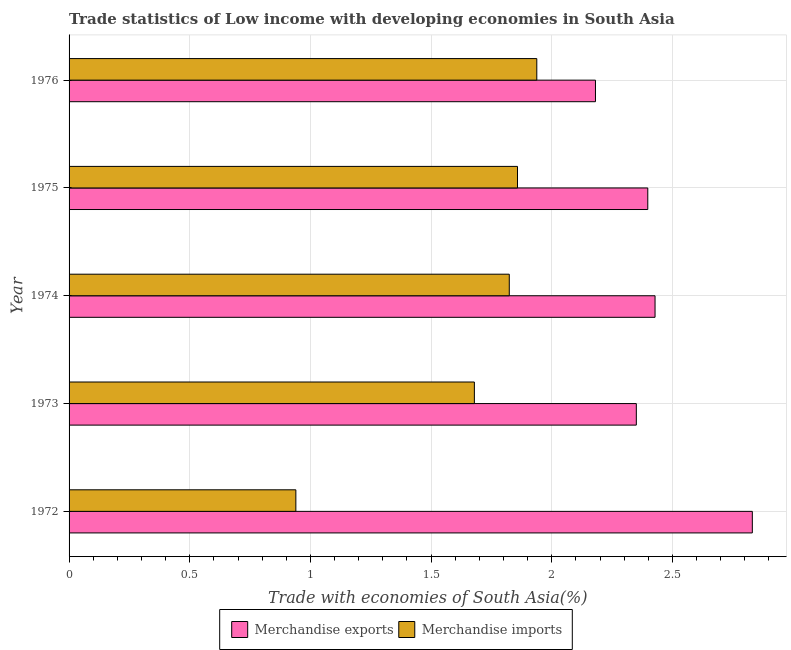How many different coloured bars are there?
Keep it short and to the point. 2. What is the label of the 1st group of bars from the top?
Your answer should be very brief. 1976. In how many cases, is the number of bars for a given year not equal to the number of legend labels?
Offer a terse response. 0. What is the merchandise imports in 1973?
Offer a terse response. 1.68. Across all years, what is the maximum merchandise exports?
Offer a terse response. 2.83. Across all years, what is the minimum merchandise exports?
Give a very brief answer. 2.18. In which year was the merchandise exports minimum?
Keep it short and to the point. 1976. What is the total merchandise exports in the graph?
Provide a succinct answer. 12.19. What is the difference between the merchandise imports in 1972 and that in 1974?
Provide a short and direct response. -0.88. What is the difference between the merchandise exports in 1976 and the merchandise imports in 1974?
Give a very brief answer. 0.36. What is the average merchandise exports per year?
Ensure brevity in your answer.  2.44. In the year 1972, what is the difference between the merchandise exports and merchandise imports?
Offer a terse response. 1.89. What is the ratio of the merchandise exports in 1972 to that in 1973?
Your response must be concise. 1.2. Is the merchandise exports in 1972 less than that in 1974?
Your answer should be compact. No. What is the difference between the highest and the second highest merchandise exports?
Keep it short and to the point. 0.4. Is the sum of the merchandise imports in 1973 and 1974 greater than the maximum merchandise exports across all years?
Your response must be concise. Yes. What does the 2nd bar from the bottom in 1972 represents?
Your answer should be very brief. Merchandise imports. Are all the bars in the graph horizontal?
Keep it short and to the point. Yes. How many years are there in the graph?
Offer a very short reply. 5. Does the graph contain any zero values?
Keep it short and to the point. No. Where does the legend appear in the graph?
Give a very brief answer. Bottom center. What is the title of the graph?
Ensure brevity in your answer.  Trade statistics of Low income with developing economies in South Asia. Does "RDB concessional" appear as one of the legend labels in the graph?
Give a very brief answer. No. What is the label or title of the X-axis?
Provide a short and direct response. Trade with economies of South Asia(%). What is the Trade with economies of South Asia(%) in Merchandise exports in 1972?
Provide a succinct answer. 2.83. What is the Trade with economies of South Asia(%) of Merchandise imports in 1972?
Your answer should be compact. 0.94. What is the Trade with economies of South Asia(%) in Merchandise exports in 1973?
Provide a short and direct response. 2.35. What is the Trade with economies of South Asia(%) of Merchandise imports in 1973?
Your response must be concise. 1.68. What is the Trade with economies of South Asia(%) in Merchandise exports in 1974?
Your answer should be very brief. 2.43. What is the Trade with economies of South Asia(%) of Merchandise imports in 1974?
Your answer should be very brief. 1.82. What is the Trade with economies of South Asia(%) of Merchandise exports in 1975?
Your answer should be very brief. 2.4. What is the Trade with economies of South Asia(%) in Merchandise imports in 1975?
Offer a terse response. 1.86. What is the Trade with economies of South Asia(%) of Merchandise exports in 1976?
Make the answer very short. 2.18. What is the Trade with economies of South Asia(%) in Merchandise imports in 1976?
Give a very brief answer. 1.94. Across all years, what is the maximum Trade with economies of South Asia(%) of Merchandise exports?
Your response must be concise. 2.83. Across all years, what is the maximum Trade with economies of South Asia(%) of Merchandise imports?
Provide a short and direct response. 1.94. Across all years, what is the minimum Trade with economies of South Asia(%) in Merchandise exports?
Make the answer very short. 2.18. Across all years, what is the minimum Trade with economies of South Asia(%) in Merchandise imports?
Give a very brief answer. 0.94. What is the total Trade with economies of South Asia(%) in Merchandise exports in the graph?
Your answer should be compact. 12.19. What is the total Trade with economies of South Asia(%) in Merchandise imports in the graph?
Your response must be concise. 8.24. What is the difference between the Trade with economies of South Asia(%) of Merchandise exports in 1972 and that in 1973?
Keep it short and to the point. 0.48. What is the difference between the Trade with economies of South Asia(%) in Merchandise imports in 1972 and that in 1973?
Ensure brevity in your answer.  -0.74. What is the difference between the Trade with economies of South Asia(%) of Merchandise exports in 1972 and that in 1974?
Your answer should be compact. 0.4. What is the difference between the Trade with economies of South Asia(%) in Merchandise imports in 1972 and that in 1974?
Keep it short and to the point. -0.88. What is the difference between the Trade with economies of South Asia(%) of Merchandise exports in 1972 and that in 1975?
Make the answer very short. 0.43. What is the difference between the Trade with economies of South Asia(%) in Merchandise imports in 1972 and that in 1975?
Keep it short and to the point. -0.92. What is the difference between the Trade with economies of South Asia(%) of Merchandise exports in 1972 and that in 1976?
Provide a succinct answer. 0.65. What is the difference between the Trade with economies of South Asia(%) of Merchandise imports in 1972 and that in 1976?
Give a very brief answer. -1. What is the difference between the Trade with economies of South Asia(%) of Merchandise exports in 1973 and that in 1974?
Your response must be concise. -0.08. What is the difference between the Trade with economies of South Asia(%) in Merchandise imports in 1973 and that in 1974?
Give a very brief answer. -0.14. What is the difference between the Trade with economies of South Asia(%) of Merchandise exports in 1973 and that in 1975?
Your answer should be compact. -0.05. What is the difference between the Trade with economies of South Asia(%) in Merchandise imports in 1973 and that in 1975?
Offer a very short reply. -0.18. What is the difference between the Trade with economies of South Asia(%) in Merchandise exports in 1973 and that in 1976?
Provide a succinct answer. 0.17. What is the difference between the Trade with economies of South Asia(%) of Merchandise imports in 1973 and that in 1976?
Provide a short and direct response. -0.26. What is the difference between the Trade with economies of South Asia(%) of Merchandise exports in 1974 and that in 1975?
Offer a very short reply. 0.03. What is the difference between the Trade with economies of South Asia(%) in Merchandise imports in 1974 and that in 1975?
Ensure brevity in your answer.  -0.03. What is the difference between the Trade with economies of South Asia(%) in Merchandise exports in 1974 and that in 1976?
Offer a very short reply. 0.25. What is the difference between the Trade with economies of South Asia(%) of Merchandise imports in 1974 and that in 1976?
Provide a short and direct response. -0.11. What is the difference between the Trade with economies of South Asia(%) of Merchandise exports in 1975 and that in 1976?
Offer a terse response. 0.22. What is the difference between the Trade with economies of South Asia(%) in Merchandise imports in 1975 and that in 1976?
Provide a short and direct response. -0.08. What is the difference between the Trade with economies of South Asia(%) in Merchandise exports in 1972 and the Trade with economies of South Asia(%) in Merchandise imports in 1973?
Provide a short and direct response. 1.15. What is the difference between the Trade with economies of South Asia(%) in Merchandise exports in 1972 and the Trade with economies of South Asia(%) in Merchandise imports in 1975?
Make the answer very short. 0.97. What is the difference between the Trade with economies of South Asia(%) of Merchandise exports in 1972 and the Trade with economies of South Asia(%) of Merchandise imports in 1976?
Ensure brevity in your answer.  0.89. What is the difference between the Trade with economies of South Asia(%) in Merchandise exports in 1973 and the Trade with economies of South Asia(%) in Merchandise imports in 1974?
Make the answer very short. 0.53. What is the difference between the Trade with economies of South Asia(%) of Merchandise exports in 1973 and the Trade with economies of South Asia(%) of Merchandise imports in 1975?
Provide a short and direct response. 0.49. What is the difference between the Trade with economies of South Asia(%) in Merchandise exports in 1973 and the Trade with economies of South Asia(%) in Merchandise imports in 1976?
Your response must be concise. 0.41. What is the difference between the Trade with economies of South Asia(%) of Merchandise exports in 1974 and the Trade with economies of South Asia(%) of Merchandise imports in 1975?
Provide a succinct answer. 0.57. What is the difference between the Trade with economies of South Asia(%) of Merchandise exports in 1974 and the Trade with economies of South Asia(%) of Merchandise imports in 1976?
Ensure brevity in your answer.  0.49. What is the difference between the Trade with economies of South Asia(%) in Merchandise exports in 1975 and the Trade with economies of South Asia(%) in Merchandise imports in 1976?
Give a very brief answer. 0.46. What is the average Trade with economies of South Asia(%) of Merchandise exports per year?
Keep it short and to the point. 2.44. What is the average Trade with economies of South Asia(%) of Merchandise imports per year?
Your response must be concise. 1.65. In the year 1972, what is the difference between the Trade with economies of South Asia(%) of Merchandise exports and Trade with economies of South Asia(%) of Merchandise imports?
Keep it short and to the point. 1.89. In the year 1973, what is the difference between the Trade with economies of South Asia(%) of Merchandise exports and Trade with economies of South Asia(%) of Merchandise imports?
Make the answer very short. 0.67. In the year 1974, what is the difference between the Trade with economies of South Asia(%) of Merchandise exports and Trade with economies of South Asia(%) of Merchandise imports?
Offer a very short reply. 0.6. In the year 1975, what is the difference between the Trade with economies of South Asia(%) of Merchandise exports and Trade with economies of South Asia(%) of Merchandise imports?
Make the answer very short. 0.54. In the year 1976, what is the difference between the Trade with economies of South Asia(%) of Merchandise exports and Trade with economies of South Asia(%) of Merchandise imports?
Provide a short and direct response. 0.24. What is the ratio of the Trade with economies of South Asia(%) of Merchandise exports in 1972 to that in 1973?
Ensure brevity in your answer.  1.2. What is the ratio of the Trade with economies of South Asia(%) of Merchandise imports in 1972 to that in 1973?
Make the answer very short. 0.56. What is the ratio of the Trade with economies of South Asia(%) of Merchandise exports in 1972 to that in 1974?
Provide a succinct answer. 1.17. What is the ratio of the Trade with economies of South Asia(%) of Merchandise imports in 1972 to that in 1974?
Ensure brevity in your answer.  0.52. What is the ratio of the Trade with economies of South Asia(%) of Merchandise exports in 1972 to that in 1975?
Your answer should be very brief. 1.18. What is the ratio of the Trade with economies of South Asia(%) of Merchandise imports in 1972 to that in 1975?
Make the answer very short. 0.51. What is the ratio of the Trade with economies of South Asia(%) of Merchandise exports in 1972 to that in 1976?
Your answer should be compact. 1.3. What is the ratio of the Trade with economies of South Asia(%) in Merchandise imports in 1972 to that in 1976?
Keep it short and to the point. 0.48. What is the ratio of the Trade with economies of South Asia(%) in Merchandise exports in 1973 to that in 1974?
Your answer should be compact. 0.97. What is the ratio of the Trade with economies of South Asia(%) in Merchandise imports in 1973 to that in 1974?
Ensure brevity in your answer.  0.92. What is the ratio of the Trade with economies of South Asia(%) of Merchandise exports in 1973 to that in 1975?
Keep it short and to the point. 0.98. What is the ratio of the Trade with economies of South Asia(%) in Merchandise imports in 1973 to that in 1975?
Provide a short and direct response. 0.9. What is the ratio of the Trade with economies of South Asia(%) in Merchandise exports in 1973 to that in 1976?
Make the answer very short. 1.08. What is the ratio of the Trade with economies of South Asia(%) in Merchandise imports in 1973 to that in 1976?
Make the answer very short. 0.87. What is the ratio of the Trade with economies of South Asia(%) in Merchandise exports in 1974 to that in 1975?
Give a very brief answer. 1.01. What is the ratio of the Trade with economies of South Asia(%) in Merchandise imports in 1974 to that in 1975?
Keep it short and to the point. 0.98. What is the ratio of the Trade with economies of South Asia(%) of Merchandise exports in 1974 to that in 1976?
Give a very brief answer. 1.11. What is the ratio of the Trade with economies of South Asia(%) of Merchandise exports in 1975 to that in 1976?
Offer a very short reply. 1.1. What is the ratio of the Trade with economies of South Asia(%) of Merchandise imports in 1975 to that in 1976?
Provide a succinct answer. 0.96. What is the difference between the highest and the second highest Trade with economies of South Asia(%) in Merchandise exports?
Your answer should be compact. 0.4. What is the difference between the highest and the second highest Trade with economies of South Asia(%) in Merchandise imports?
Your answer should be compact. 0.08. What is the difference between the highest and the lowest Trade with economies of South Asia(%) of Merchandise exports?
Give a very brief answer. 0.65. What is the difference between the highest and the lowest Trade with economies of South Asia(%) of Merchandise imports?
Your answer should be compact. 1. 